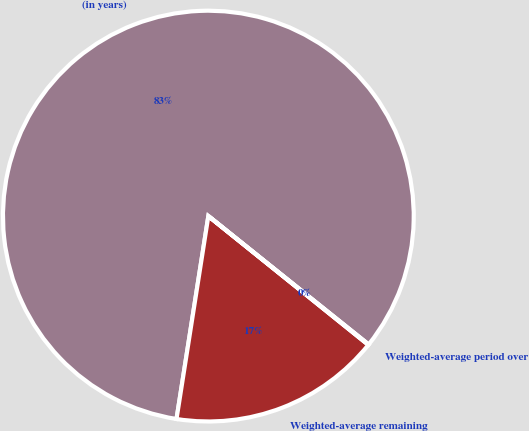Convert chart to OTSL. <chart><loc_0><loc_0><loc_500><loc_500><pie_chart><fcel>(in years)<fcel>Weighted-average remaining<fcel>Weighted-average period over<nl><fcel>83.27%<fcel>16.69%<fcel>0.04%<nl></chart> 